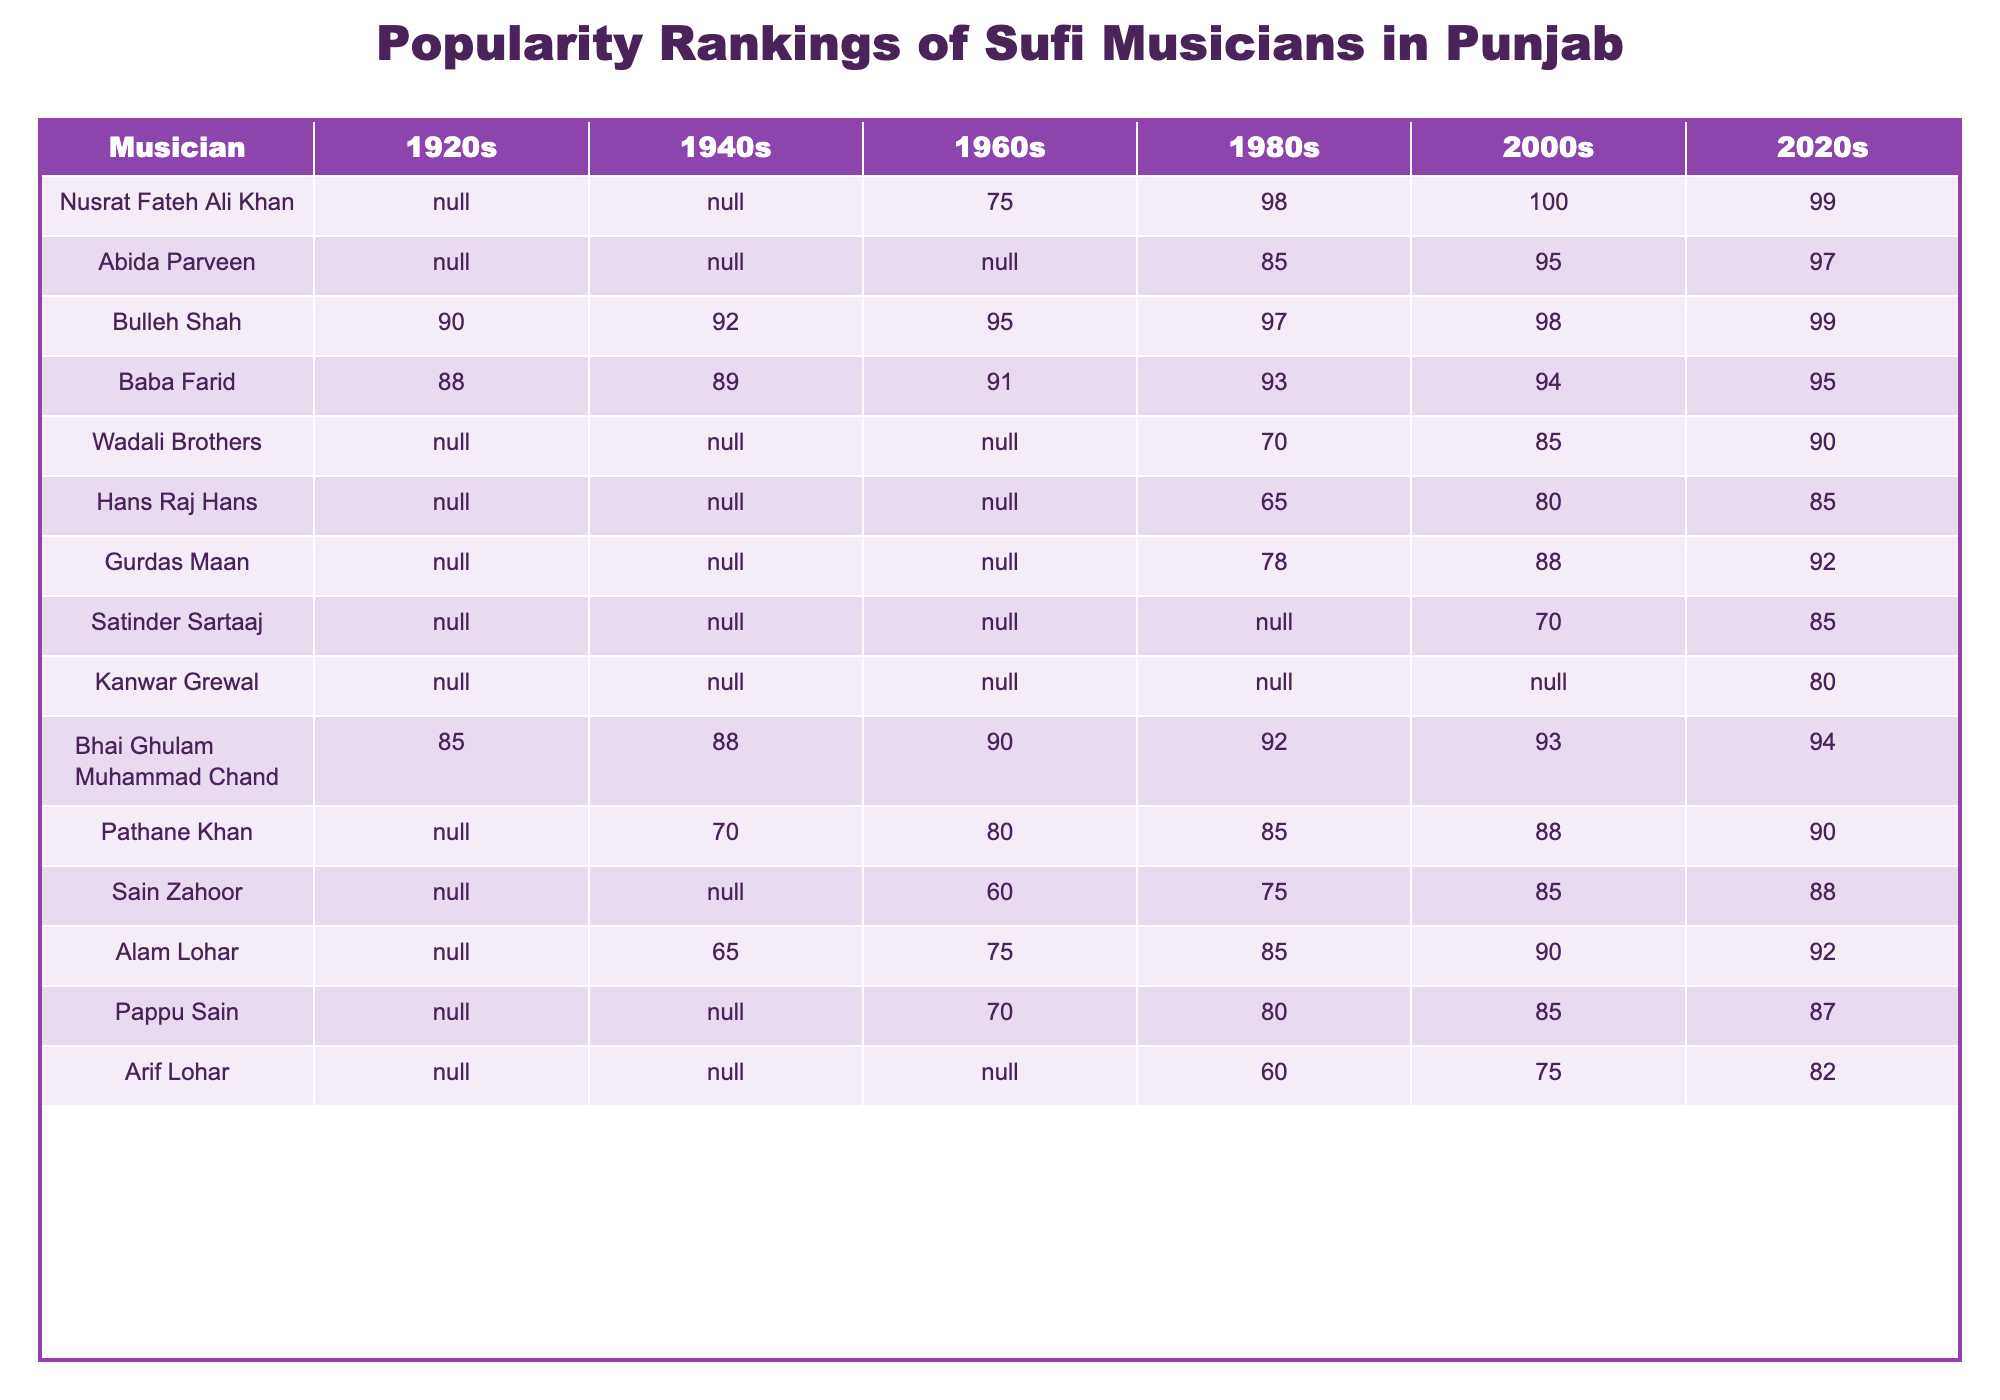What musician had the highest popularity ranking in the 1980s? Looking at the 1980s column, Nusrat Fateh Ali Khan has a ranking of 98, which is higher than any other musician listed in that decade.
Answer: Nusrat Fateh Ali Khan Which musician consistently ranks in the top three from the 1960s to the 2020s? The table shows Bulleh Shah's rankings: 95 in the 1960s, 97 in the 1980s, 98 in the 2000s, and 99 in the 2020s. He remains in the top three throughout these decades.
Answer: Bulleh Shah What is the average ranking of the Wadali Brothers across the decades provided? The Wadali Brothers have rankings of 70 (1980s), 85 (2000s), and 90 (2020s). Summing these (70 + 85 + 90) gives 245. Dividing by 3 gives an average ranking of 81.67, which we can round to 82.
Answer: 82 Did Arif Lohar rank in the 1960s? According to the table, there is no value listed for Arif Lohar in the 1960s column, which indicates that he did not have a ranking during that decade.
Answer: No Which musician's popularity ranking increased from the 2000s to the 2020s? By comparing the 2000s ranking (70 in Satinder Sartaaj's case) to the 2020s ranking (85), it is clear that Satinder Sartaaj saw an increase in popularity during this period.
Answer: Satinder Sartaaj What was the ranking of Bhai Ghulam Muhammad Chand in the 1940s? The 1940s column lists Bhai Ghulam Muhammad Chand with a ranking of 88, showing a respectable popularity during that decade.
Answer: 88 How does Abida Parveen's ranking in the 2020s compare to her ranking in the 1980s? In the 1980s, Abida Parveen had a ranking of 85, while in the 2020s, her ranking is 97. This indicates an increase of 12 points in her popularity over the decades.
Answer: Increased by 12 points Who had the lowest ranking in the 2000s among those listed? In the 2000s column, the lowest ranking is recorded for Arif Lohar at 75. No other musician from the list scored lower in that decade.
Answer: Arif Lohar Which musician has a steadily increasing popularity ranking over the decades? Reviewing the rankings, Bulleh Shah shows consistent improvement: from 90 (1920s) to 99 (2020s). This indicates a steady increase in popularity throughout the decades.
Answer: Bulleh Shah What was the difference in rankings between Hans Raj Hans in the 1980s and the 2020s? Hans Raj Hans was ranked 65 in the 1980s and 85 in the 2020s. The difference is 85 - 65 = 20.
Answer: 20 